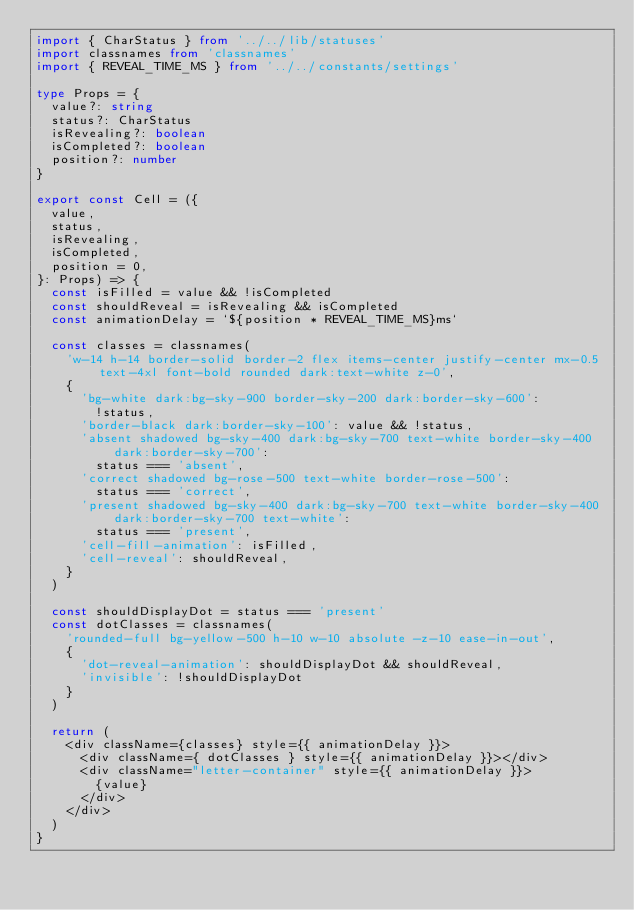Convert code to text. <code><loc_0><loc_0><loc_500><loc_500><_TypeScript_>import { CharStatus } from '../../lib/statuses'
import classnames from 'classnames'
import { REVEAL_TIME_MS } from '../../constants/settings'

type Props = {
  value?: string
  status?: CharStatus
  isRevealing?: boolean
  isCompleted?: boolean
  position?: number
}

export const Cell = ({
  value,
  status,
  isRevealing,
  isCompleted,
  position = 0,
}: Props) => {
  const isFilled = value && !isCompleted
  const shouldReveal = isRevealing && isCompleted
  const animationDelay = `${position * REVEAL_TIME_MS}ms`

  const classes = classnames(
    'w-14 h-14 border-solid border-2 flex items-center justify-center mx-0.5 text-4xl font-bold rounded dark:text-white z-0',
    {
      'bg-white dark:bg-sky-900 border-sky-200 dark:border-sky-600':
        !status,
      'border-black dark:border-sky-100': value && !status,
      'absent shadowed bg-sky-400 dark:bg-sky-700 text-white border-sky-400 dark:border-sky-700':
        status === 'absent',
      'correct shadowed bg-rose-500 text-white border-rose-500':
        status === 'correct',
      'present shadowed bg-sky-400 dark:bg-sky-700 text-white border-sky-400 dark:border-sky-700 text-white':
        status === 'present',
      'cell-fill-animation': isFilled,
      'cell-reveal': shouldReveal,
    }
  )

  const shouldDisplayDot = status === 'present'
  const dotClasses = classnames(
    'rounded-full bg-yellow-500 h-10 w-10 absolute -z-10 ease-in-out',
    {
      'dot-reveal-animation': shouldDisplayDot && shouldReveal,
      'invisible': !shouldDisplayDot
    }
  )

  return (
    <div className={classes} style={{ animationDelay }}>
      <div className={ dotClasses } style={{ animationDelay }}></div>
      <div className="letter-container" style={{ animationDelay }}>
        {value}
      </div>
    </div>
  )
}
</code> 